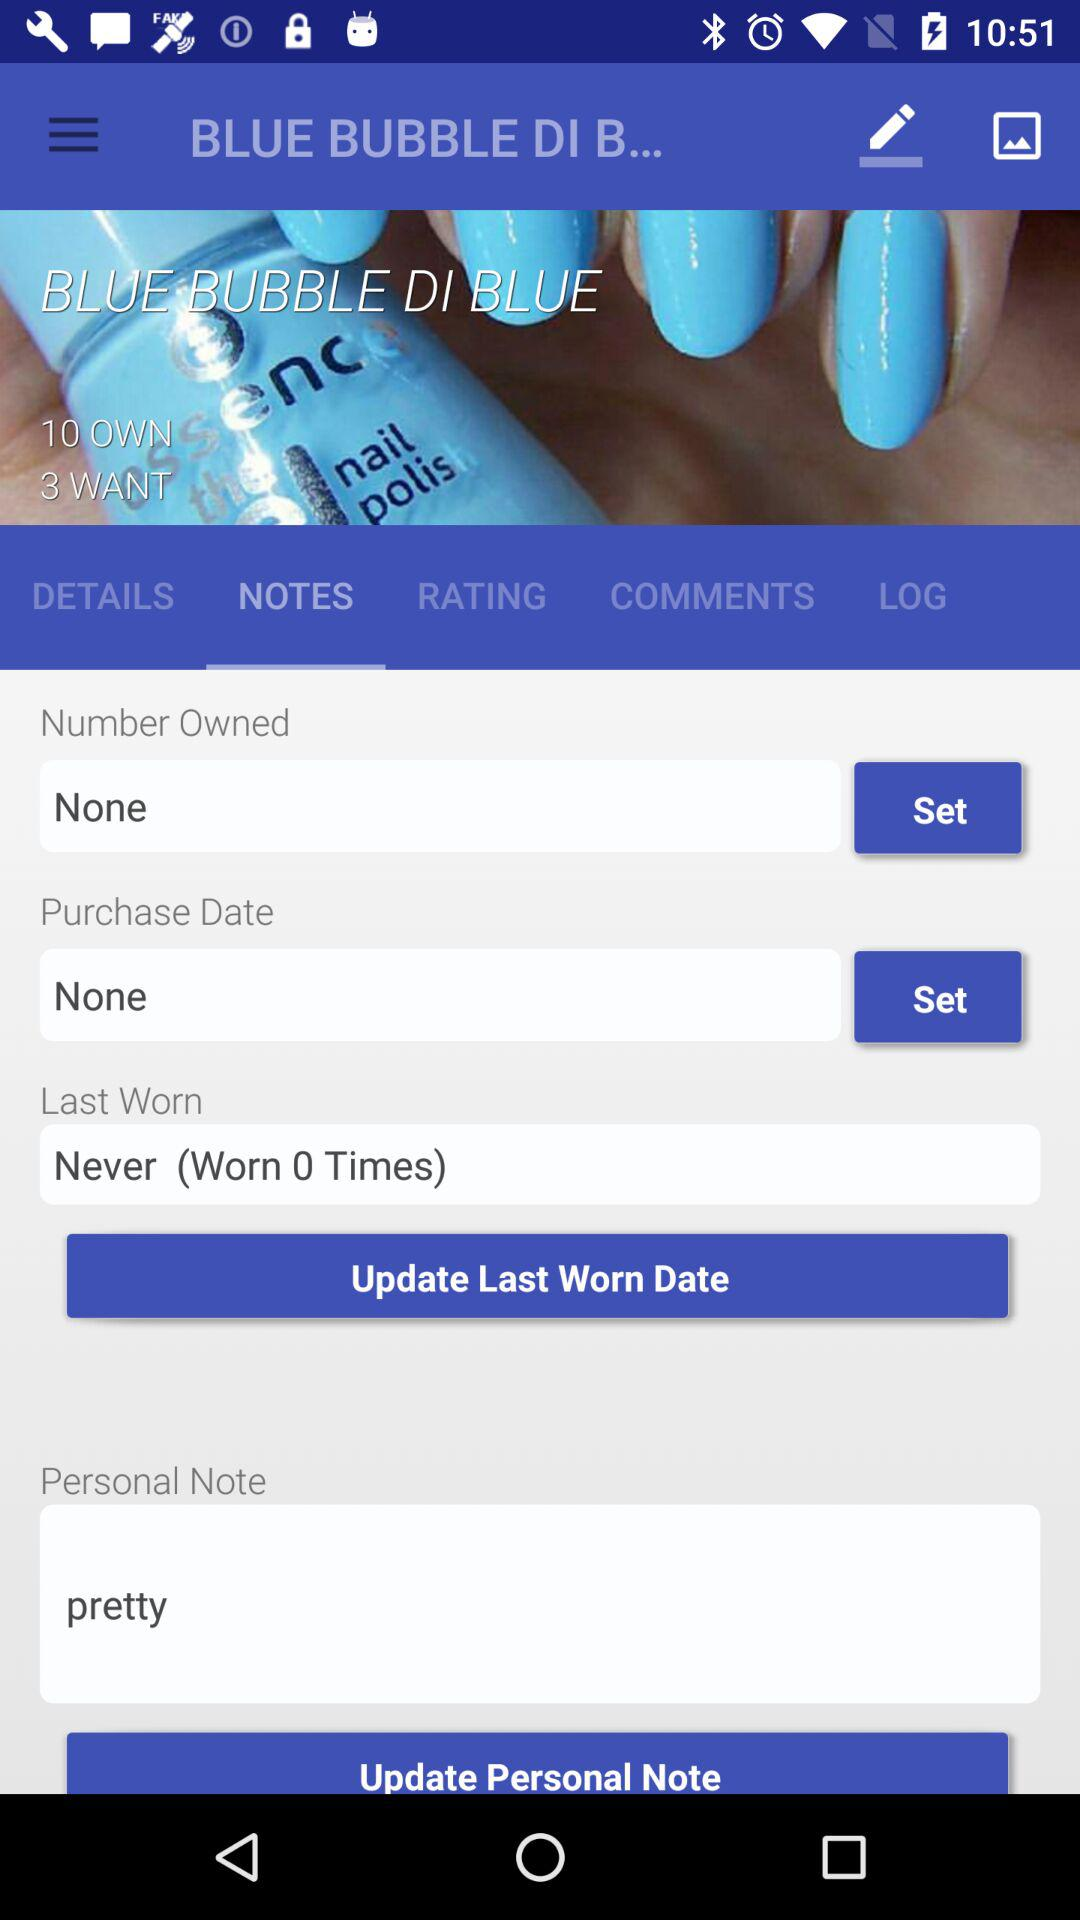Which option is selected in Blue Bubble, Di Blue? The selected option is "NOTES". 